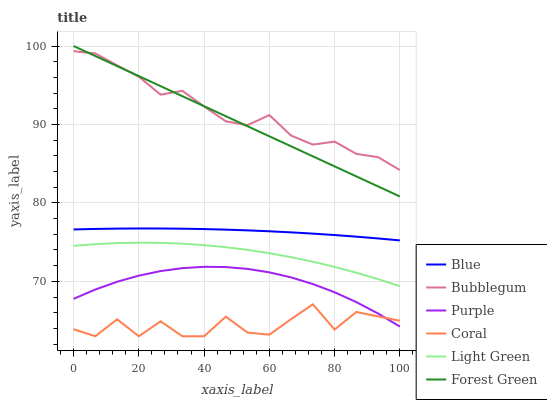Does Coral have the minimum area under the curve?
Answer yes or no. Yes. Does Bubblegum have the maximum area under the curve?
Answer yes or no. Yes. Does Purple have the minimum area under the curve?
Answer yes or no. No. Does Purple have the maximum area under the curve?
Answer yes or no. No. Is Forest Green the smoothest?
Answer yes or no. Yes. Is Coral the roughest?
Answer yes or no. Yes. Is Purple the smoothest?
Answer yes or no. No. Is Purple the roughest?
Answer yes or no. No. Does Coral have the lowest value?
Answer yes or no. Yes. Does Purple have the lowest value?
Answer yes or no. No. Does Forest Green have the highest value?
Answer yes or no. Yes. Does Purple have the highest value?
Answer yes or no. No. Is Light Green less than Forest Green?
Answer yes or no. Yes. Is Bubblegum greater than Coral?
Answer yes or no. Yes. Does Bubblegum intersect Forest Green?
Answer yes or no. Yes. Is Bubblegum less than Forest Green?
Answer yes or no. No. Is Bubblegum greater than Forest Green?
Answer yes or no. No. Does Light Green intersect Forest Green?
Answer yes or no. No. 